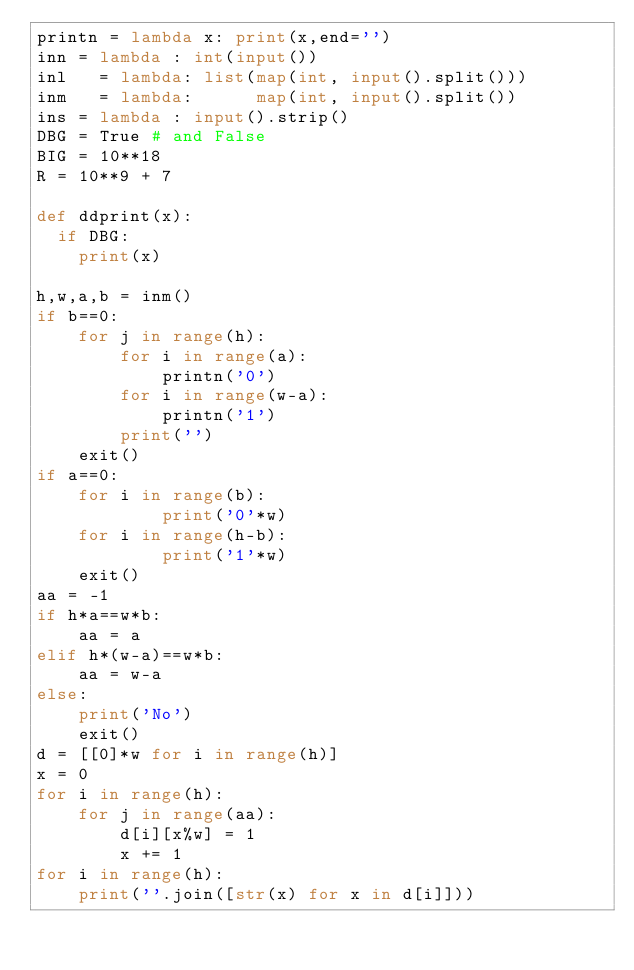Convert code to text. <code><loc_0><loc_0><loc_500><loc_500><_Python_>printn = lambda x: print(x,end='')
inn = lambda : int(input())
inl   = lambda: list(map(int, input().split()))
inm   = lambda:      map(int, input().split())
ins = lambda : input().strip()
DBG = True # and False
BIG = 10**18
R = 10**9 + 7

def ddprint(x):
  if DBG:
    print(x)

h,w,a,b = inm()
if b==0:
    for j in range(h):
        for i in range(a):
            printn('0')
        for i in range(w-a):
            printn('1')
        print('')
    exit()
if a==0:
    for i in range(b):
            print('0'*w)
    for i in range(h-b):
            print('1'*w)
    exit()
aa = -1
if h*a==w*b:
    aa = a
elif h*(w-a)==w*b:
    aa = w-a
else:
    print('No')
    exit()
d = [[0]*w for i in range(h)]
x = 0
for i in range(h):
    for j in range(aa):
        d[i][x%w] = 1
        x += 1
for i in range(h):
    print(''.join([str(x) for x in d[i]]))
</code> 